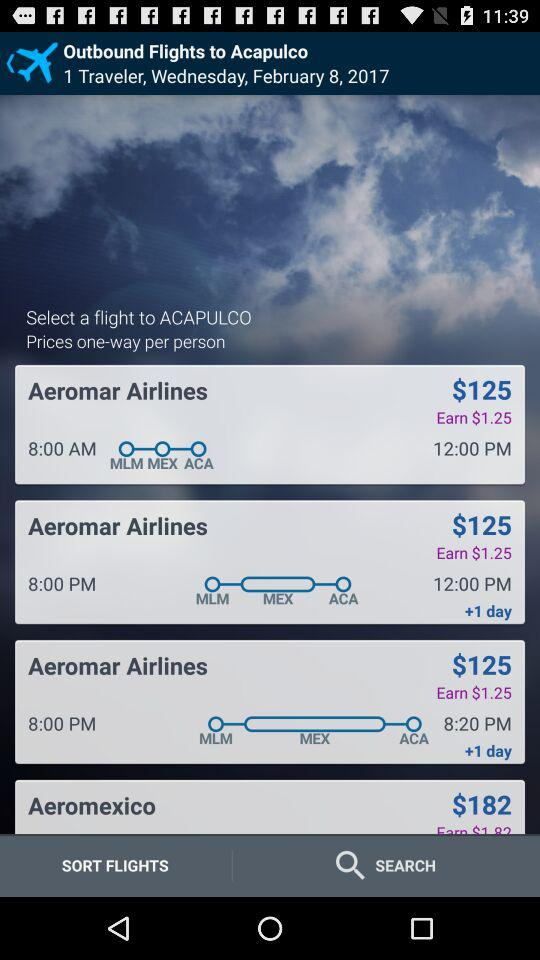What is the fare per person for a one-way ticket on "Aeromar Airlines"? The fare per person for a one-way ticket on "Aeromar Airlines" is $125. 